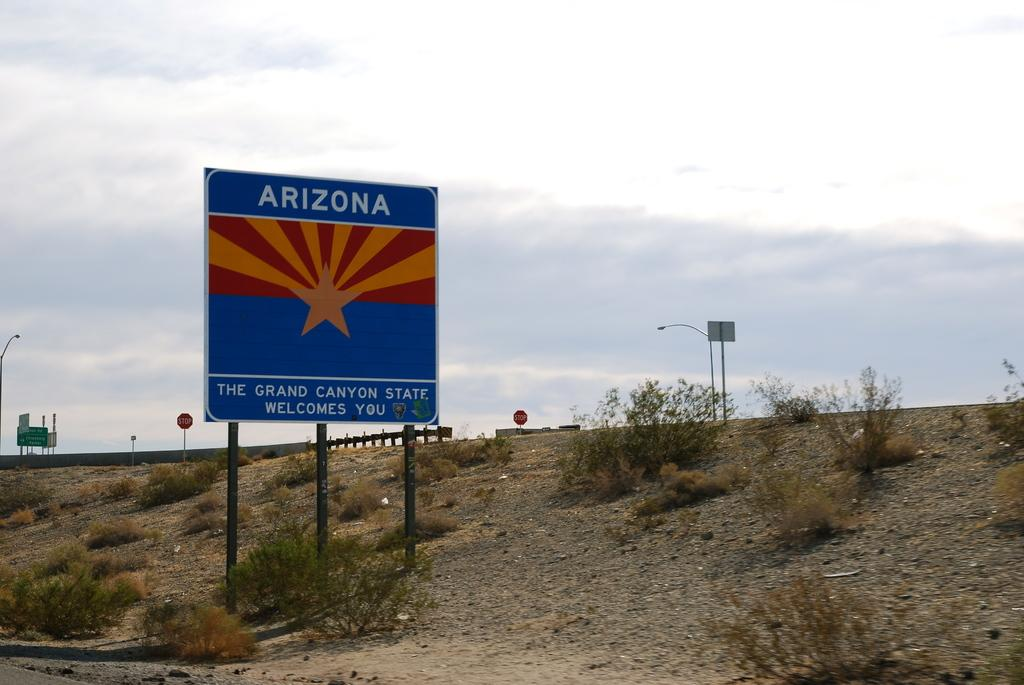Provide a one-sentence caption for the provided image. a road sign for Arizona on the side of a road. 